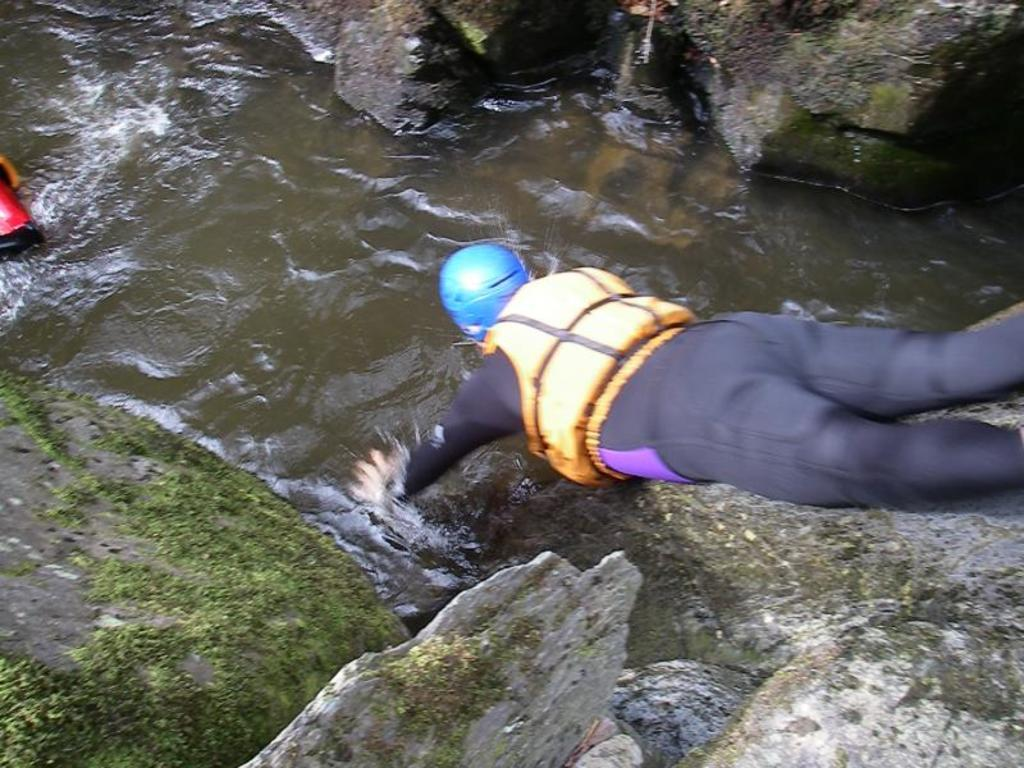What is the position of the man in the image? The man is laying in the image. What is the man wearing on his head? The man is wearing a blue color helmet. What type of natural elements can be seen in the image? There are rocks and water visible in the image. How is the water positioned in relation to the rocks? The water is floating in between the rocks. What type of plant is growing out of the man's helmet in the image? There is no plant growing out of the man's helmet in the image; he is wearing a blue color helmet. 